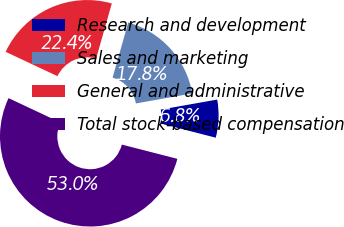Convert chart. <chart><loc_0><loc_0><loc_500><loc_500><pie_chart><fcel>Research and development<fcel>Sales and marketing<fcel>General and administrative<fcel>Total stock-based compensation<nl><fcel>6.79%<fcel>17.8%<fcel>22.42%<fcel>52.99%<nl></chart> 